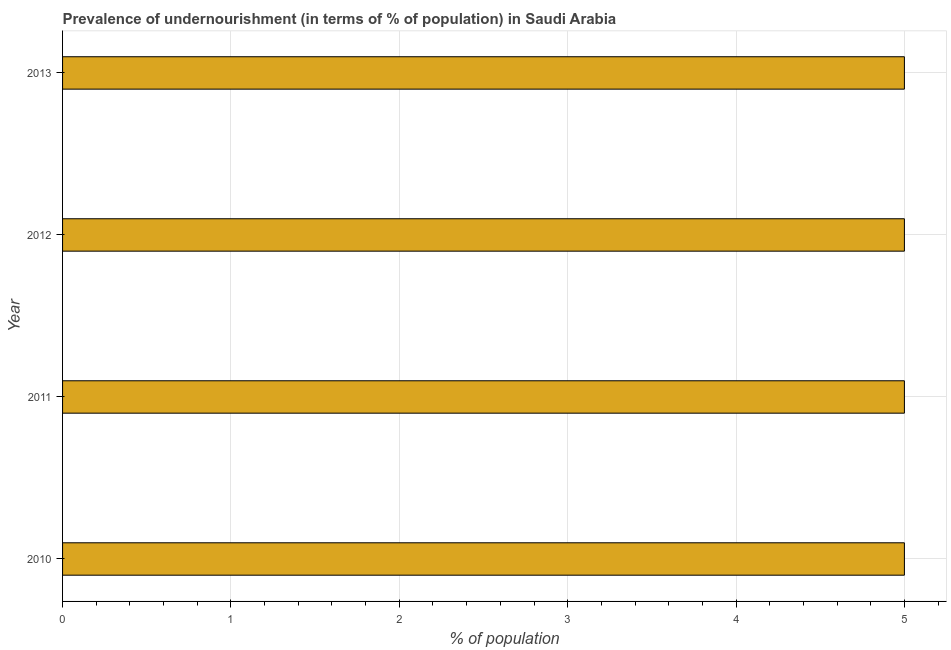Does the graph contain any zero values?
Offer a very short reply. No. Does the graph contain grids?
Offer a very short reply. Yes. What is the title of the graph?
Keep it short and to the point. Prevalence of undernourishment (in terms of % of population) in Saudi Arabia. What is the label or title of the X-axis?
Your answer should be very brief. % of population. What is the label or title of the Y-axis?
Give a very brief answer. Year. What is the percentage of undernourished population in 2012?
Offer a very short reply. 5. Do a majority of the years between 2011 and 2012 (inclusive) have percentage of undernourished population greater than 4 %?
Keep it short and to the point. Yes. What is the ratio of the percentage of undernourished population in 2010 to that in 2011?
Your response must be concise. 1. Is the percentage of undernourished population in 2010 less than that in 2013?
Your response must be concise. No. What is the difference between the highest and the second highest percentage of undernourished population?
Offer a very short reply. 0. Is the sum of the percentage of undernourished population in 2012 and 2013 greater than the maximum percentage of undernourished population across all years?
Give a very brief answer. Yes. In how many years, is the percentage of undernourished population greater than the average percentage of undernourished population taken over all years?
Make the answer very short. 0. How many bars are there?
Offer a terse response. 4. What is the difference between two consecutive major ticks on the X-axis?
Offer a terse response. 1. Are the values on the major ticks of X-axis written in scientific E-notation?
Your answer should be very brief. No. What is the % of population of 2010?
Provide a succinct answer. 5. What is the % of population of 2012?
Your answer should be compact. 5. What is the % of population of 2013?
Offer a very short reply. 5. What is the difference between the % of population in 2010 and 2012?
Your answer should be very brief. 0. What is the difference between the % of population in 2010 and 2013?
Offer a terse response. 0. What is the difference between the % of population in 2012 and 2013?
Offer a very short reply. 0. What is the ratio of the % of population in 2010 to that in 2011?
Your response must be concise. 1. What is the ratio of the % of population in 2010 to that in 2013?
Ensure brevity in your answer.  1. What is the ratio of the % of population in 2011 to that in 2012?
Provide a succinct answer. 1. What is the ratio of the % of population in 2011 to that in 2013?
Your response must be concise. 1. What is the ratio of the % of population in 2012 to that in 2013?
Offer a terse response. 1. 